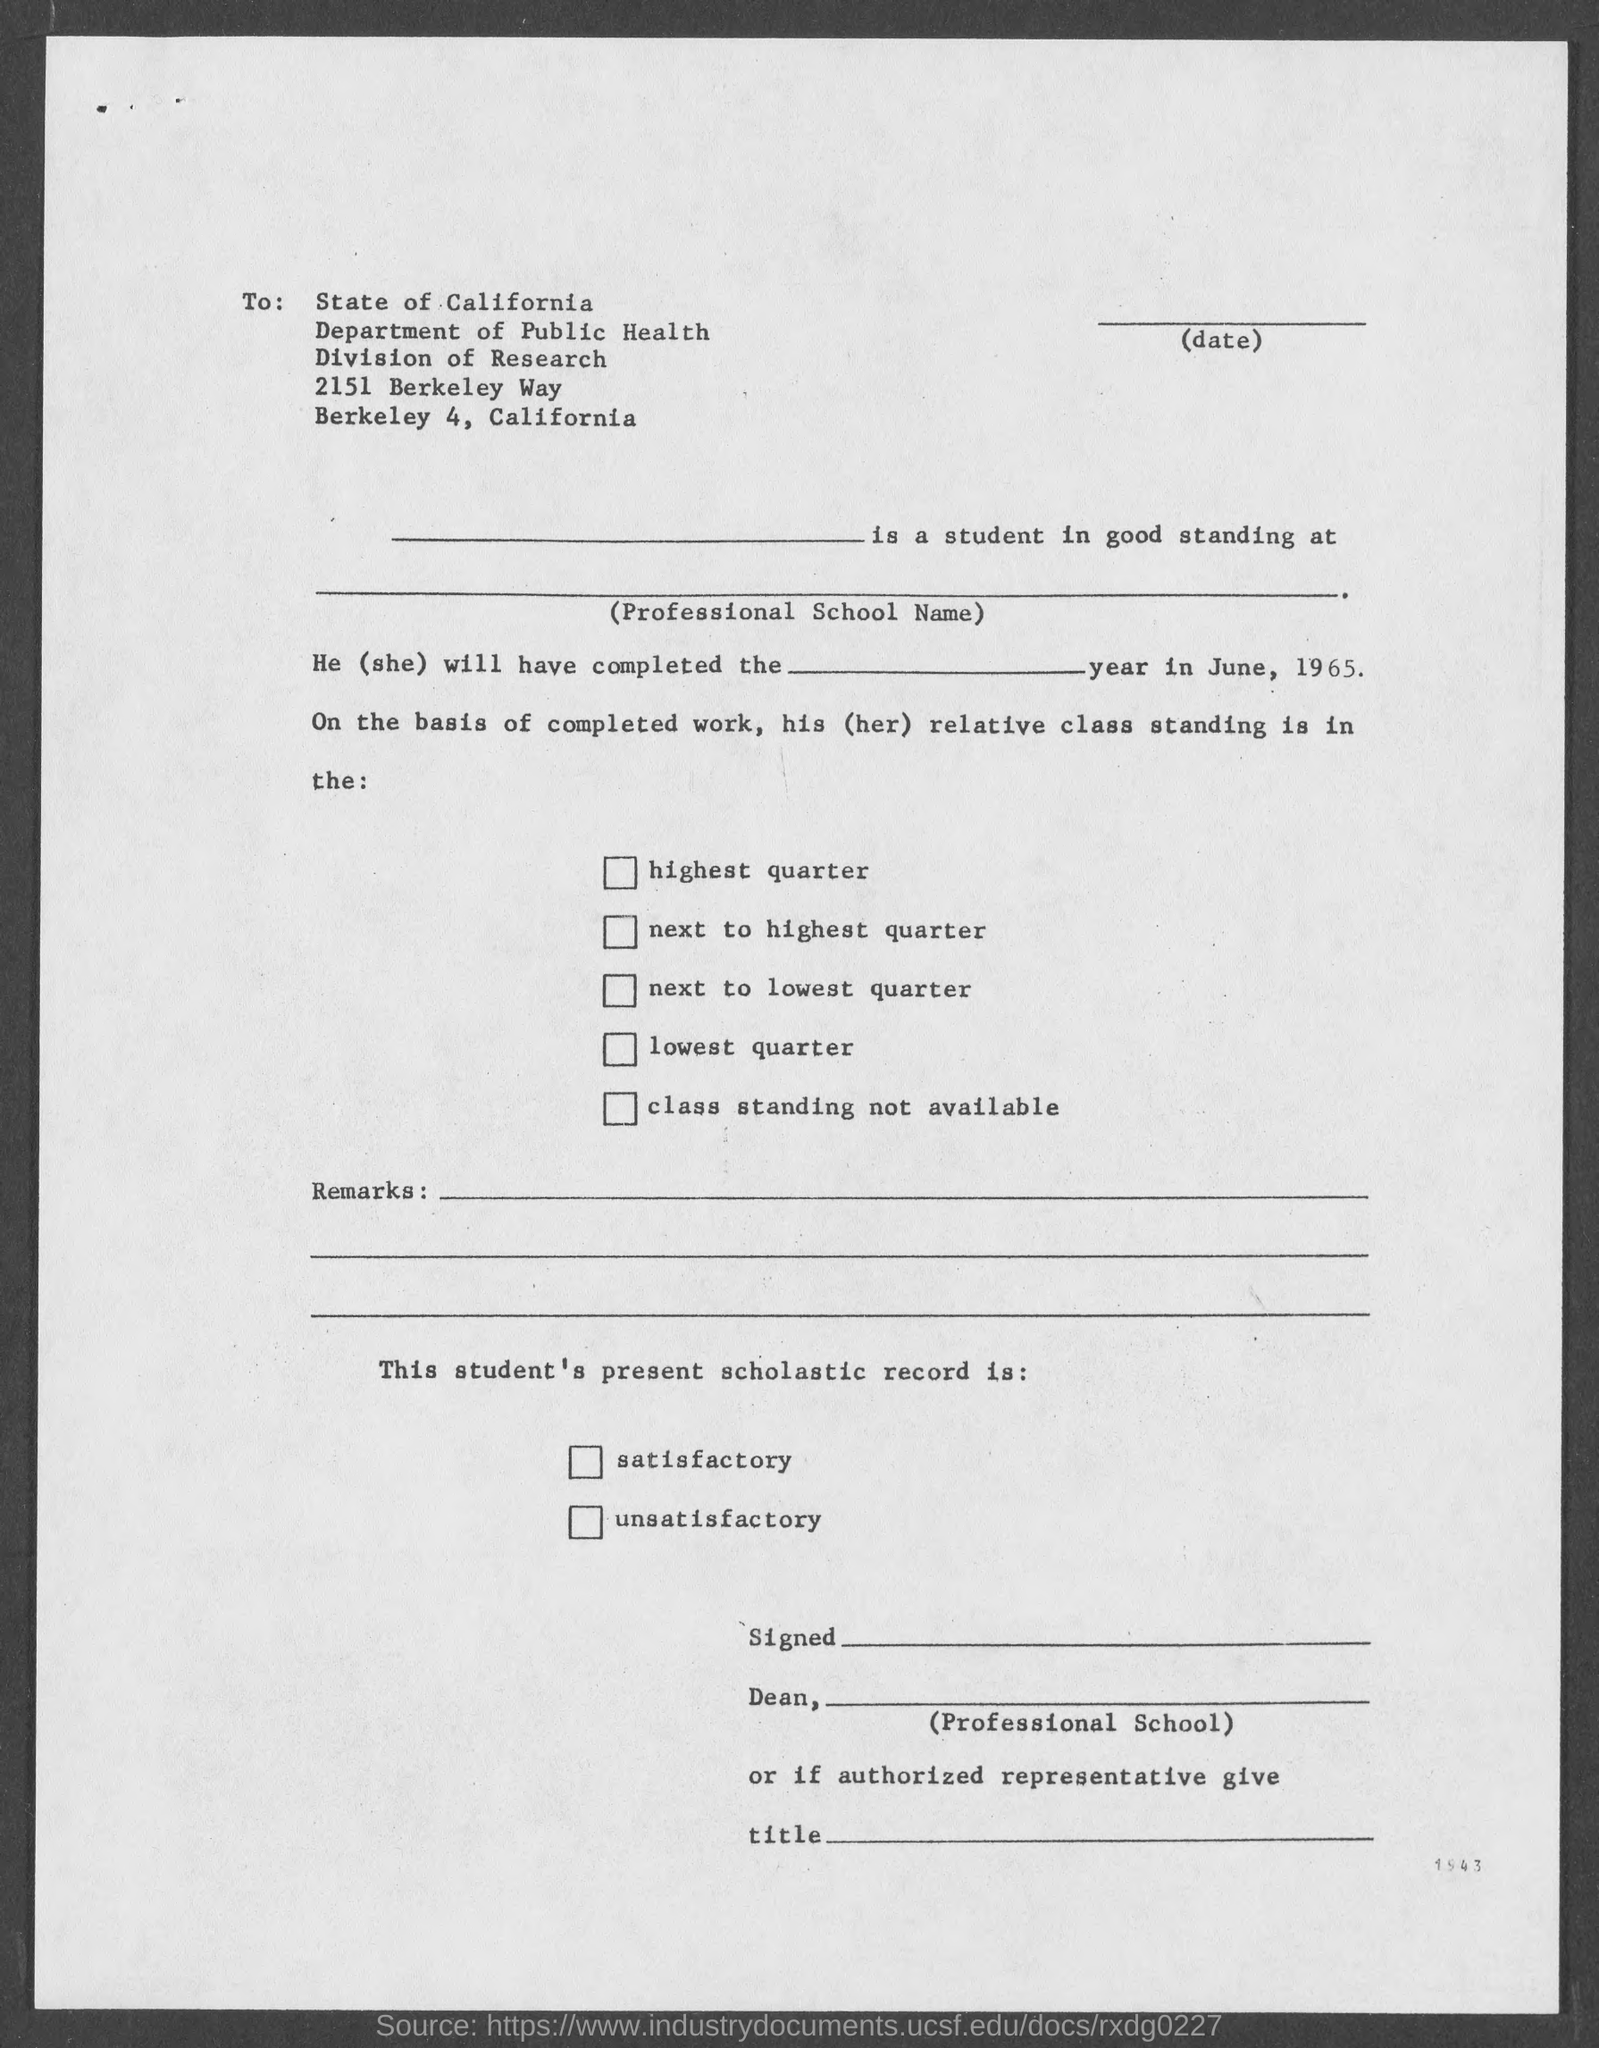To whom the letter was sent ?
Keep it short and to the point. STATE OF CALIFORNIA. What is the name of the department mentioned in the given form ?
Ensure brevity in your answer.  PUBLIC HEALTH. What is the division mentioned in the given page ?
Ensure brevity in your answer.  Division of research. 